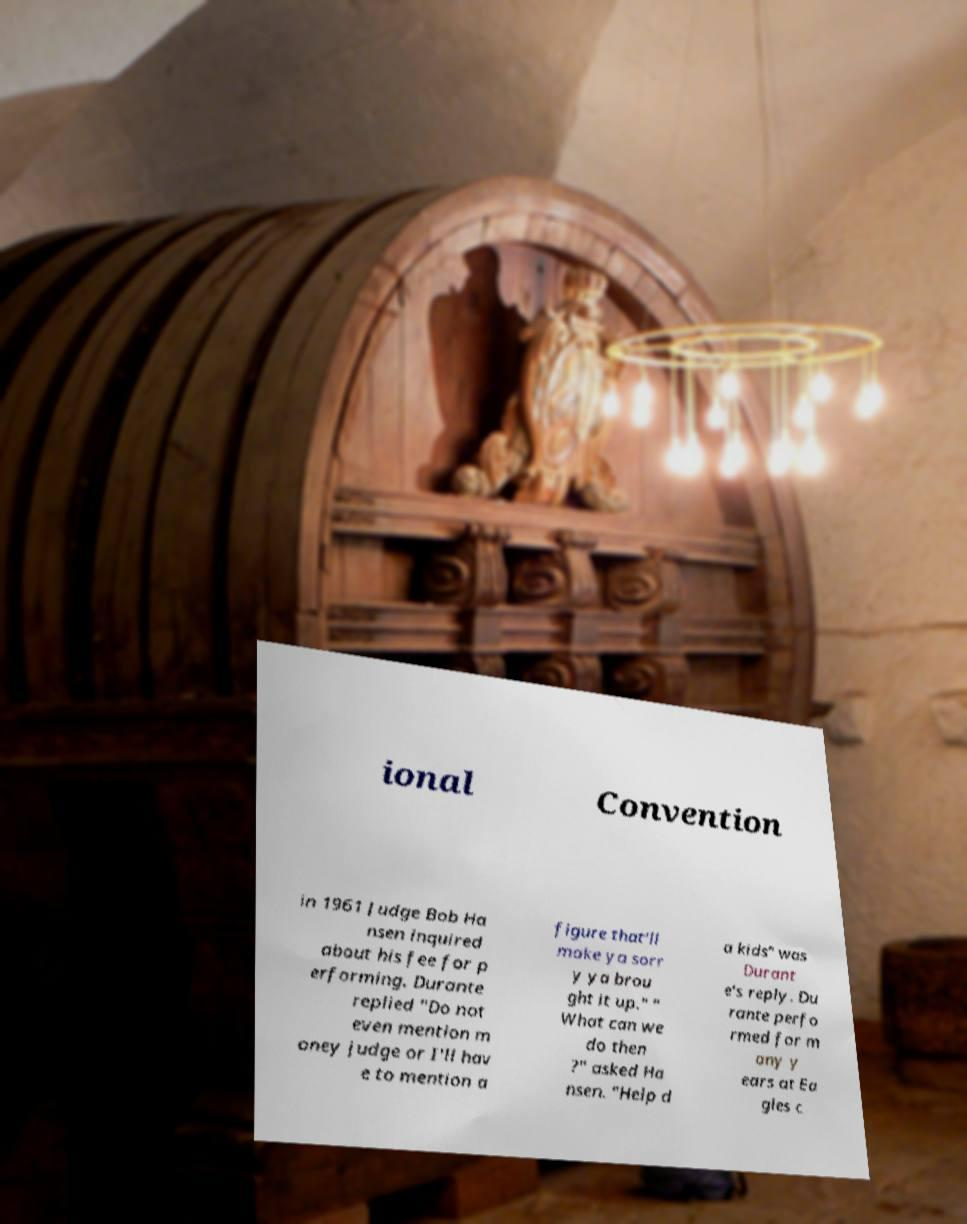For documentation purposes, I need the text within this image transcribed. Could you provide that? ional Convention in 1961 Judge Bob Ha nsen inquired about his fee for p erforming. Durante replied "Do not even mention m oney judge or I'll hav e to mention a figure that'll make ya sorr y ya brou ght it up." " What can we do then ?" asked Ha nsen. "Help d a kids" was Durant e's reply. Du rante perfo rmed for m any y ears at Ea gles c 